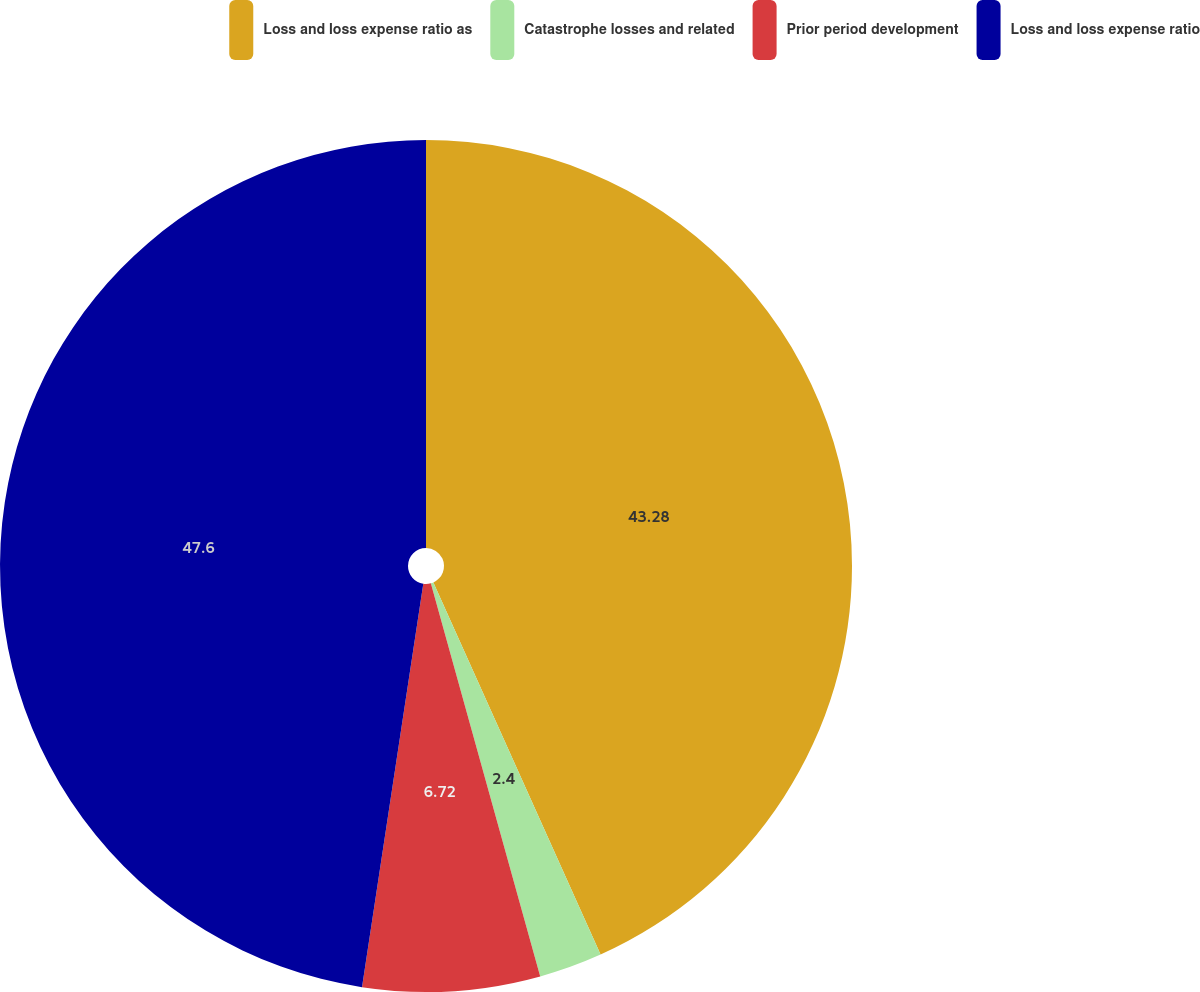Convert chart. <chart><loc_0><loc_0><loc_500><loc_500><pie_chart><fcel>Loss and loss expense ratio as<fcel>Catastrophe losses and related<fcel>Prior period development<fcel>Loss and loss expense ratio<nl><fcel>43.28%<fcel>2.4%<fcel>6.72%<fcel>47.6%<nl></chart> 